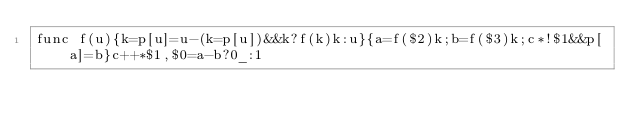<code> <loc_0><loc_0><loc_500><loc_500><_Awk_>func f(u){k=p[u]=u-(k=p[u])&&k?f(k)k:u}{a=f($2)k;b=f($3)k;c*!$1&&p[a]=b}c++*$1,$0=a-b?0_:1</code> 